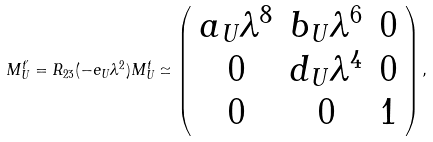<formula> <loc_0><loc_0><loc_500><loc_500>M _ { U } ^ { t ^ { \prime } } = R _ { 2 3 } ( - e _ { U } \lambda ^ { 2 } ) M _ { U } ^ { t } \simeq \left ( \begin{array} { c c c } a _ { U } \lambda ^ { 8 } & b _ { U } \lambda ^ { 6 } & 0 \\ 0 & d _ { U } \lambda ^ { 4 } & 0 \\ 0 & 0 & 1 \\ \end{array} \right ) ,</formula> 